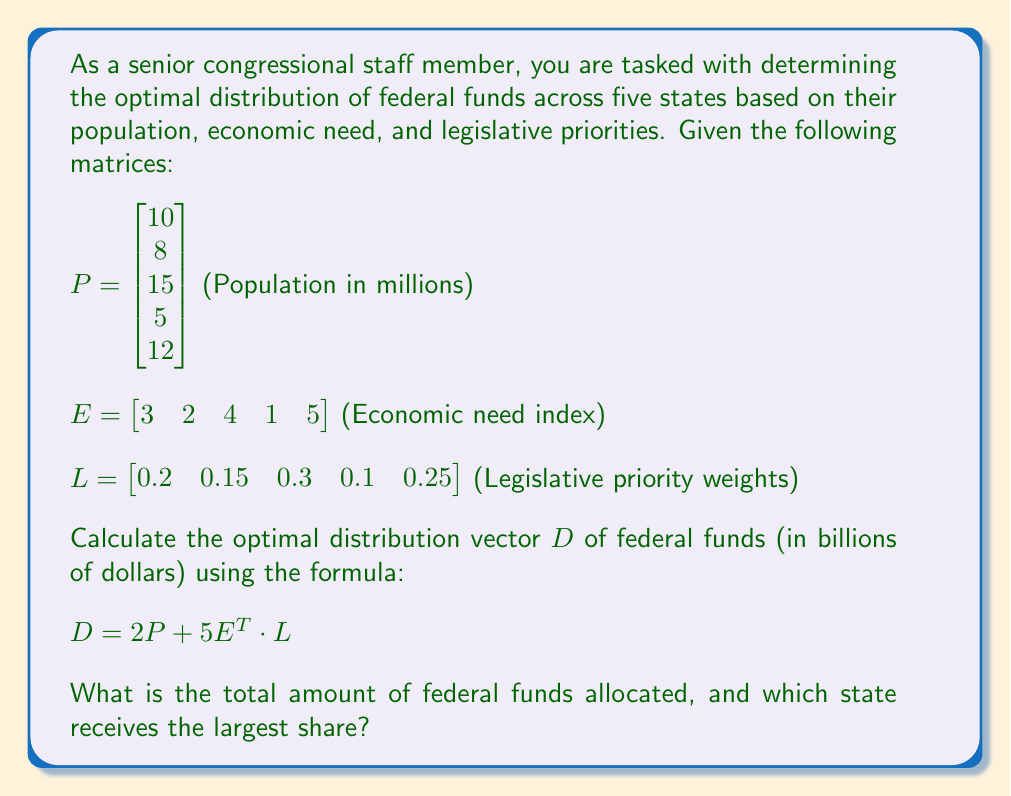Could you help me with this problem? To solve this problem, we'll follow these steps:

1. Calculate $2P$
2. Calculate $E^T \cdot L$
3. Calculate $5(E^T \cdot L)$
4. Sum the results from steps 1 and 3 to get $D$
5. Find the total amount and the state with the largest share

Step 1: Calculate $2P$
$$2P = 2 \begin{bmatrix} 10 \\ 8 \\ 15 \\ 5 \\ 12 \end{bmatrix} = \begin{bmatrix} 20 \\ 16 \\ 30 \\ 10 \\ 24 \end{bmatrix}$$

Step 2: Calculate $E^T \cdot L$
First, we need to transpose $E$:
$$E^T = \begin{bmatrix} 3 \\ 2 \\ 4 \\ 1 \\ 5 \end{bmatrix}$$

Now, we multiply $E^T$ by $L$:
$$E^T \cdot L = [3(0.2) + 2(0.15) + 4(0.3) + 1(0.1) + 5(0.25)] = 3.15$$

Step 3: Calculate $5(E^T \cdot L)$
$$5(E^T \cdot L) = 5(3.15) = 15.75$$

Step 4: Sum the results to get $D$
$$D = 2P + 5E^T \cdot L = \begin{bmatrix} 20 \\ 16 \\ 30 \\ 10 \\ 24 \end{bmatrix} + \begin{bmatrix} 15.75 \\ 15.75 \\ 15.75 \\ 15.75 \\ 15.75 \end{bmatrix} = \begin{bmatrix} 35.75 \\ 31.75 \\ 45.75 \\ 25.75 \\ 39.75 \end{bmatrix}$$

Step 5: Find the total amount and the state with the largest share
The total amount of federal funds allocated is the sum of all elements in $D$:
$$35.75 + 31.75 + 45.75 + 25.75 + 39.75 = 178.75$$ billion dollars

The largest share goes to the state with the highest value in $D$, which is 45.75 billion dollars (the third state).
Answer: The total amount of federal funds allocated is $178.75 billion. The state receiving the largest share is the third state, with $45.75 billion. 